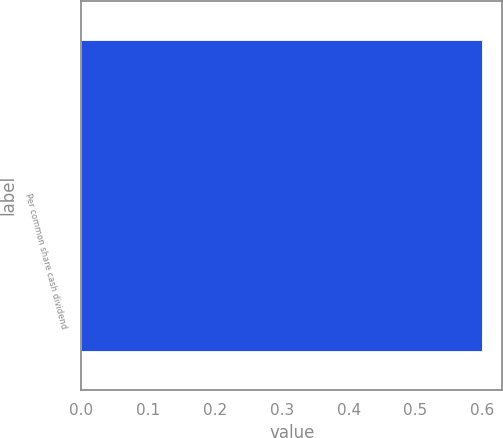<chart> <loc_0><loc_0><loc_500><loc_500><bar_chart><fcel>Per common share cash dividend<nl><fcel>0.6<nl></chart> 